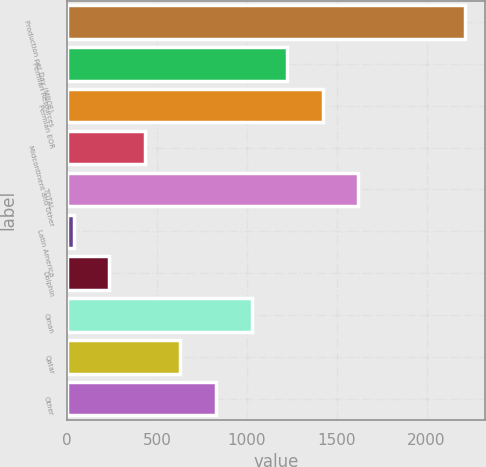Convert chart to OTSL. <chart><loc_0><loc_0><loc_500><loc_500><bar_chart><fcel>Production per Day (MBOE)<fcel>Permian Resources<fcel>Permian EOR<fcel>Midcontinent and Other<fcel>TOTAL<fcel>Latin America<fcel>Dolphin<fcel>Oman<fcel>Qatar<fcel>Other<nl><fcel>2212.8<fcel>1223.8<fcel>1421.6<fcel>432.6<fcel>1619.4<fcel>37<fcel>234.8<fcel>1026<fcel>630.4<fcel>828.2<nl></chart> 